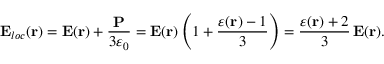<formula> <loc_0><loc_0><loc_500><loc_500>{ E } _ { l o c } ( { r } ) = { E } ( { r } ) + \frac { P } { 3 \varepsilon _ { 0 } } = { E } ( { r } ) \left ( 1 + \frac { \varepsilon ( { r } ) - 1 } { 3 } \right ) = \frac { \varepsilon ( { r } ) + 2 } { 3 } \, { E } ( { r } ) .</formula> 